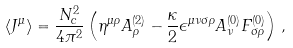Convert formula to latex. <formula><loc_0><loc_0><loc_500><loc_500>\langle J ^ { \mu } \rangle = \frac { N _ { c } ^ { 2 } } { 4 \pi ^ { 2 } } \left ( \eta ^ { \mu \rho } A ^ { ( 2 ) } _ { \rho } - \frac { \kappa } { 2 } \epsilon ^ { \mu \nu \sigma \rho } A ^ { ( 0 ) } _ { \nu } F ^ { ( 0 ) } _ { \sigma \rho } \right ) \, ,</formula> 